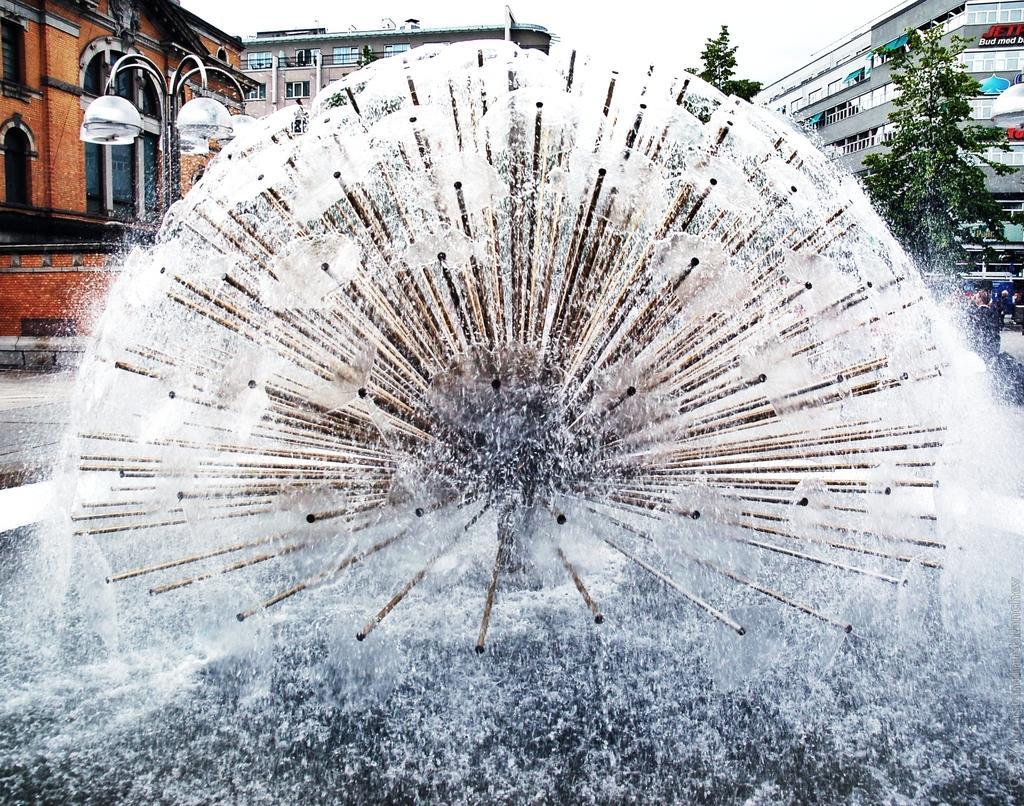Describe this image in one or two sentences. Here we can see water fountain. On the background we can see buildings,trees and sky. 